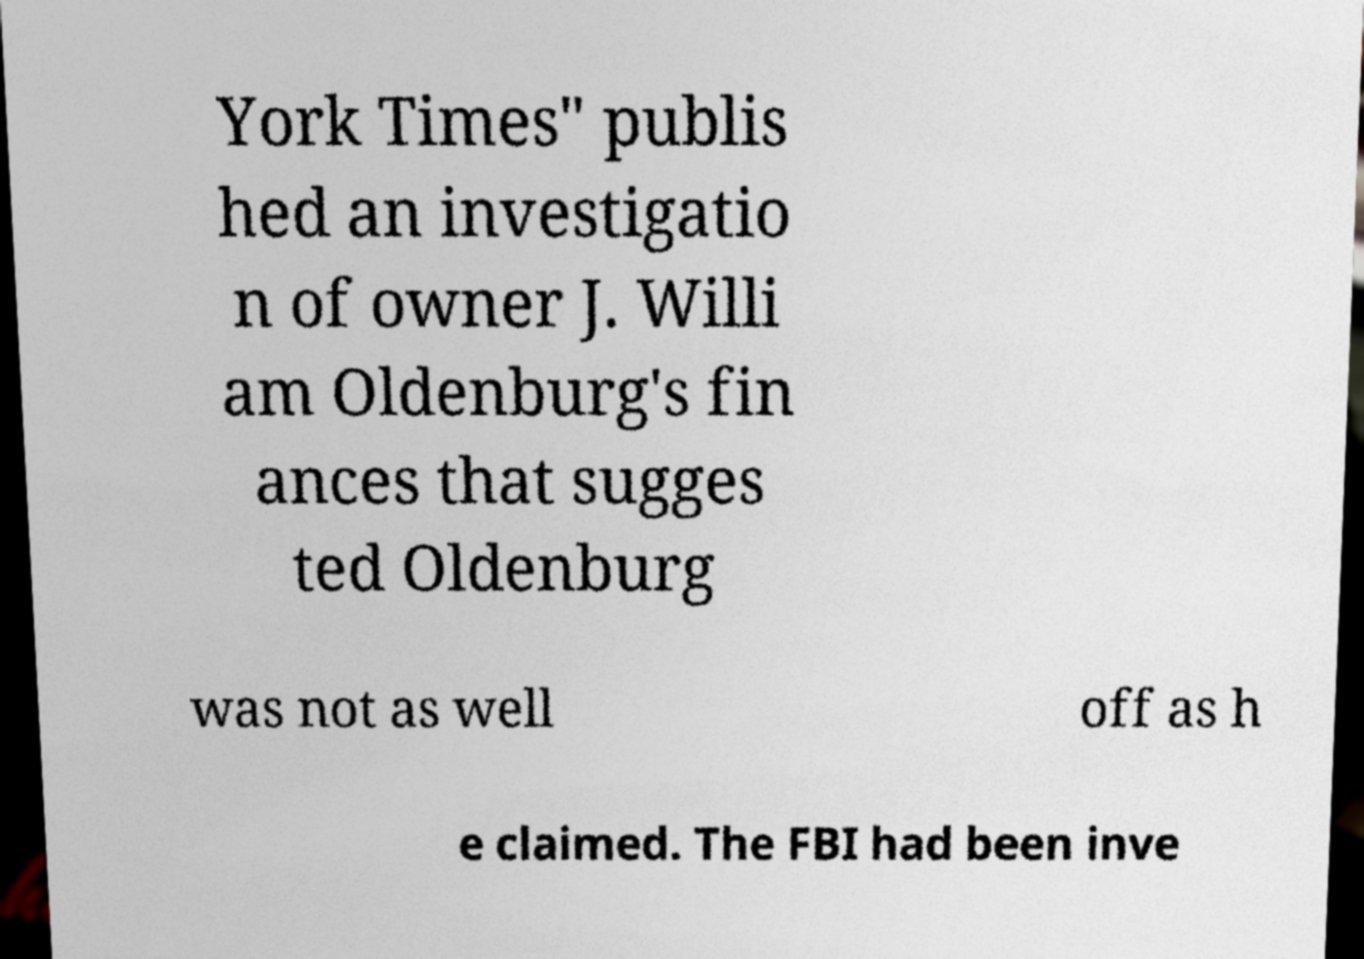Can you accurately transcribe the text from the provided image for me? York Times" publis hed an investigatio n of owner J. Willi am Oldenburg's fin ances that sugges ted Oldenburg was not as well off as h e claimed. The FBI had been inve 